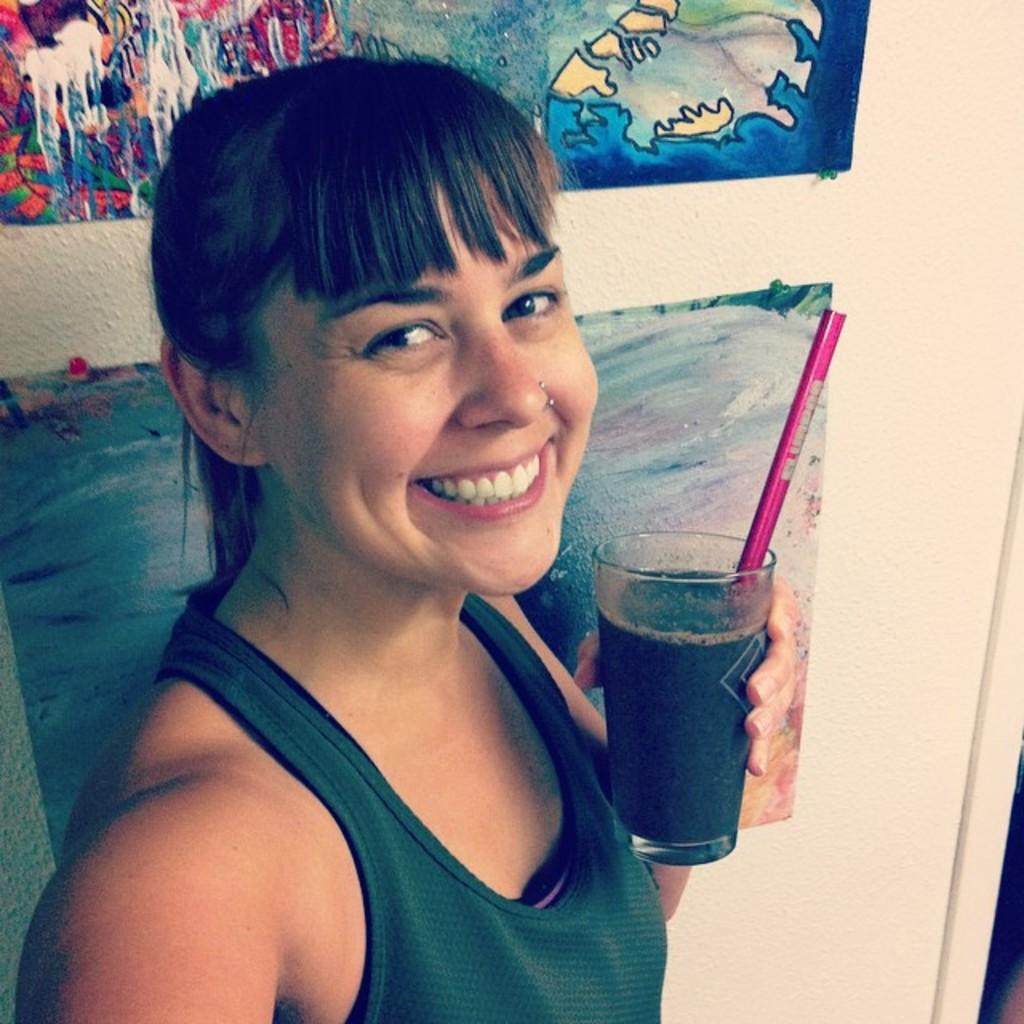What is the person in the image doing? The person is holding a glass with a drink in it. What can be seen behind the person in the image? There is a wall visible in the image. What is attached to the wall in the image? There are papers attached to the wall with pins. What type of whip can be seen in the person's hand in the image? There is no whip present in the person's hand or in the image. 